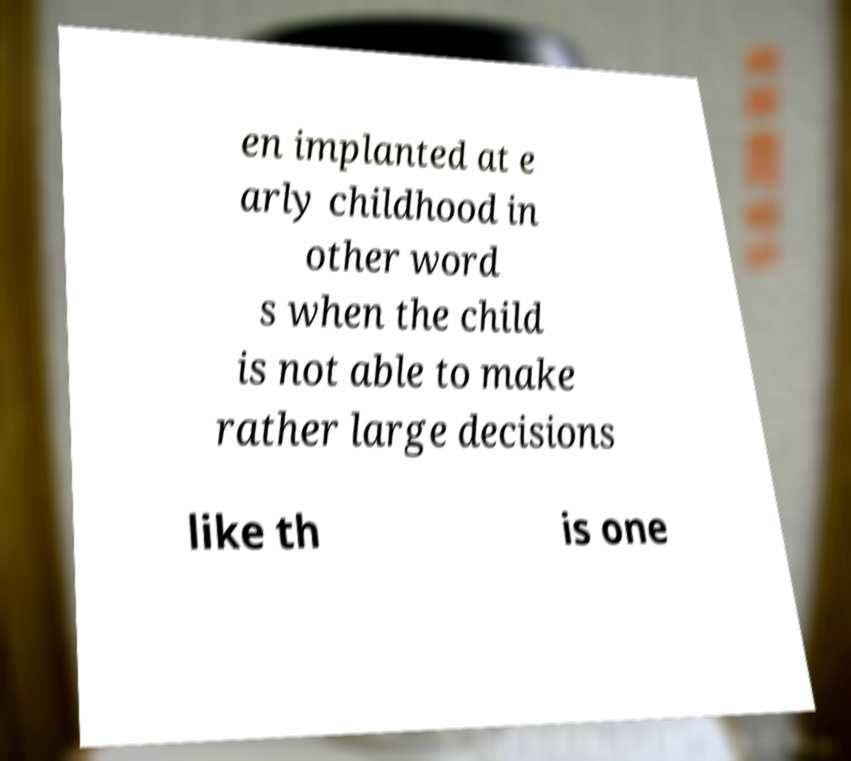What messages or text are displayed in this image? I need them in a readable, typed format. en implanted at e arly childhood in other word s when the child is not able to make rather large decisions like th is one 